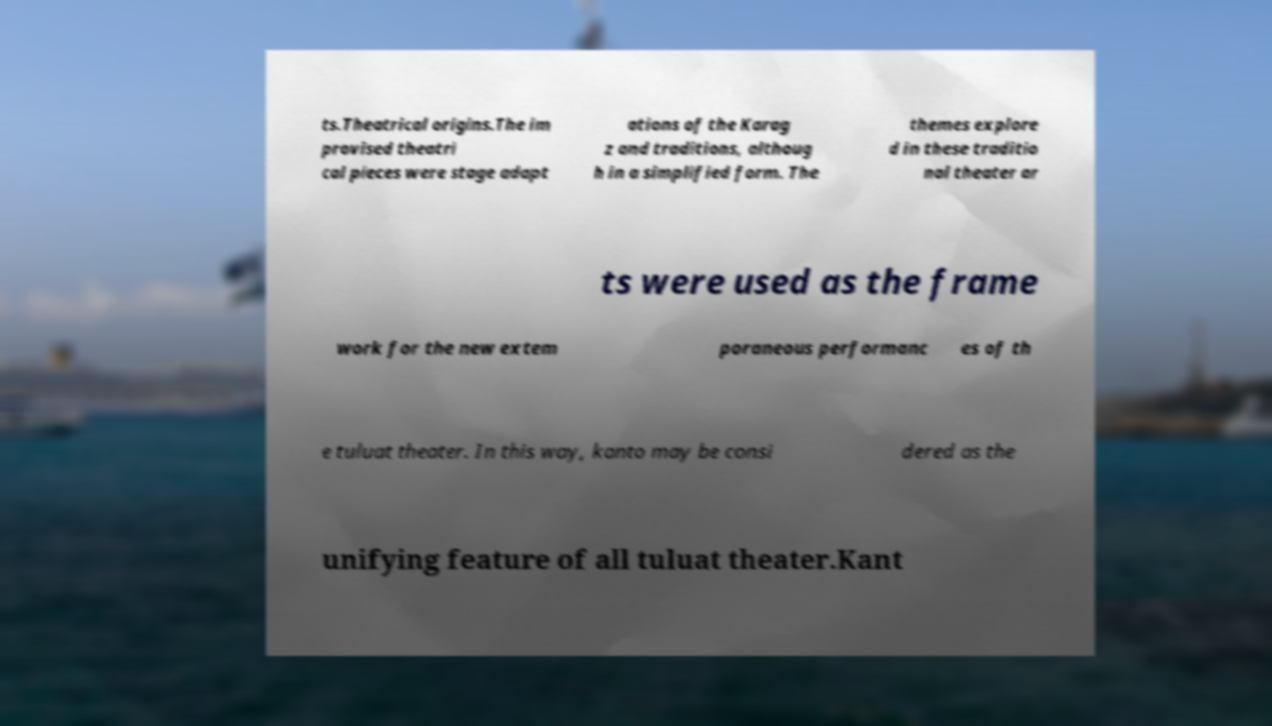There's text embedded in this image that I need extracted. Can you transcribe it verbatim? ts.Theatrical origins.The im provised theatri cal pieces were stage adapt ations of the Karag z and traditions, althoug h in a simplified form. The themes explore d in these traditio nal theater ar ts were used as the frame work for the new extem poraneous performanc es of th e tuluat theater. In this way, kanto may be consi dered as the unifying feature of all tuluat theater.Kant 